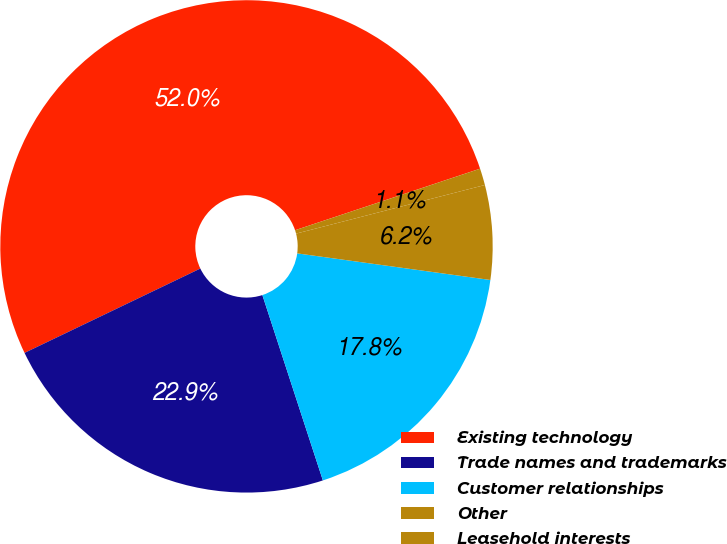Convert chart. <chart><loc_0><loc_0><loc_500><loc_500><pie_chart><fcel>Existing technology<fcel>Trade names and trademarks<fcel>Customer relationships<fcel>Other<fcel>Leasehold interests<nl><fcel>52.01%<fcel>22.9%<fcel>17.8%<fcel>6.19%<fcel>1.1%<nl></chart> 